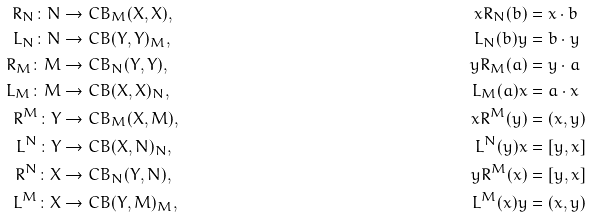<formula> <loc_0><loc_0><loc_500><loc_500>R _ { N } \colon N & \to C B _ { M } ( X , X ) , & x R _ { N } ( b ) & = x \cdot b \\ L _ { N } \colon N & \to C B ( Y , Y ) _ { M } , & L _ { N } ( b ) y & = b \cdot y \\ R _ { M } \colon M & \to C B _ { N } ( Y , Y ) , & y R _ { M } ( a ) & = y \cdot a \\ L _ { M } \colon M & \to C B ( X , X ) _ { N } , & L _ { M } ( a ) x & = a \cdot x \\ R ^ { M } \colon Y & \to C B _ { M } ( X , M ) , & x R ^ { M } ( y ) & = ( x , y ) \\ L ^ { N } \colon Y & \to C B ( X , N ) _ { N } , & L ^ { N } ( y ) x & = [ y , x ] \\ R ^ { N } \colon X & \to C B _ { N } ( Y , N ) , & y R ^ { M } ( x ) & = [ y , x ] \\ L ^ { M } \colon X & \to C B ( Y , M ) _ { M } , & L ^ { M } ( x ) y & = ( x , y )</formula> 